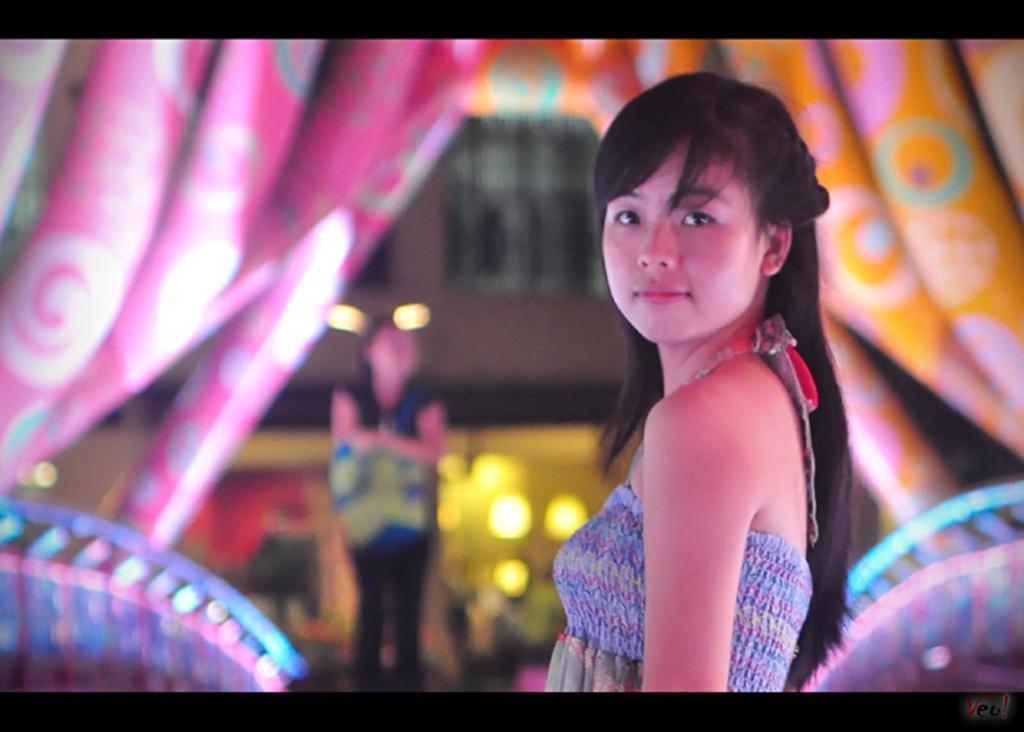In one or two sentences, can you explain what this image depicts? In this image there is a girl in the middle. In the background there are curtains. This picture is taken in the nighttime. 